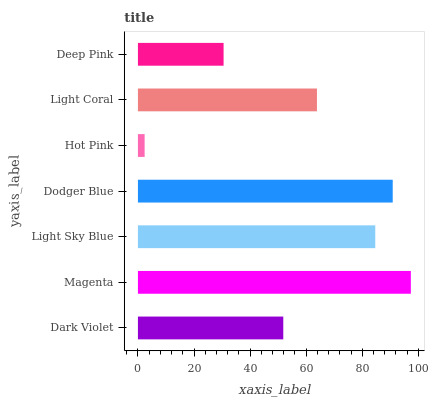Is Hot Pink the minimum?
Answer yes or no. Yes. Is Magenta the maximum?
Answer yes or no. Yes. Is Light Sky Blue the minimum?
Answer yes or no. No. Is Light Sky Blue the maximum?
Answer yes or no. No. Is Magenta greater than Light Sky Blue?
Answer yes or no. Yes. Is Light Sky Blue less than Magenta?
Answer yes or no. Yes. Is Light Sky Blue greater than Magenta?
Answer yes or no. No. Is Magenta less than Light Sky Blue?
Answer yes or no. No. Is Light Coral the high median?
Answer yes or no. Yes. Is Light Coral the low median?
Answer yes or no. Yes. Is Deep Pink the high median?
Answer yes or no. No. Is Magenta the low median?
Answer yes or no. No. 